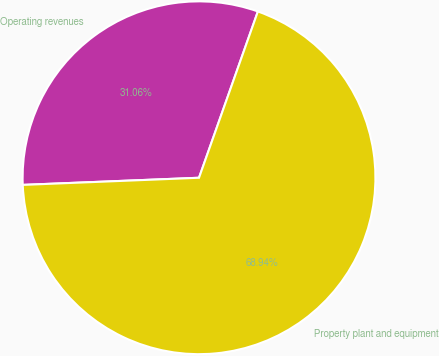<chart> <loc_0><loc_0><loc_500><loc_500><pie_chart><fcel>Operating revenues<fcel>Property plant and equipment<nl><fcel>31.06%<fcel>68.94%<nl></chart> 